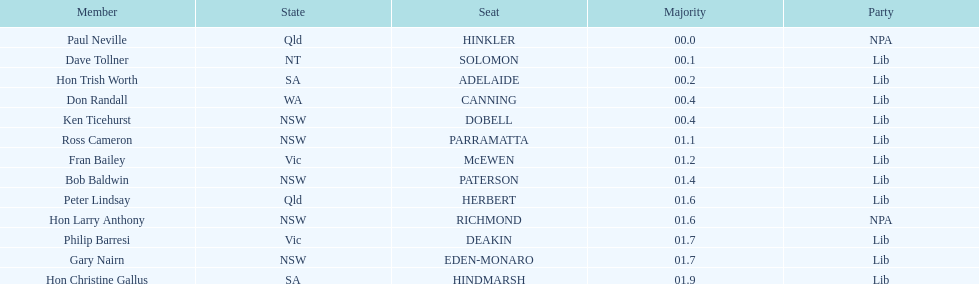What is the difference in majority between hindmarsh and hinkler? 01.9. I'm looking to parse the entire table for insights. Could you assist me with that? {'header': ['Member', 'State', 'Seat', 'Majority', 'Party'], 'rows': [['Paul Neville', 'Qld', 'HINKLER', '00.0', 'NPA'], ['Dave Tollner', 'NT', 'SOLOMON', '00.1', 'Lib'], ['Hon Trish Worth', 'SA', 'ADELAIDE', '00.2', 'Lib'], ['Don Randall', 'WA', 'CANNING', '00.4', 'Lib'], ['Ken Ticehurst', 'NSW', 'DOBELL', '00.4', 'Lib'], ['Ross Cameron', 'NSW', 'PARRAMATTA', '01.1', 'Lib'], ['Fran Bailey', 'Vic', 'McEWEN', '01.2', 'Lib'], ['Bob Baldwin', 'NSW', 'PATERSON', '01.4', 'Lib'], ['Peter Lindsay', 'Qld', 'HERBERT', '01.6', 'Lib'], ['Hon Larry Anthony', 'NSW', 'RICHMOND', '01.6', 'NPA'], ['Philip Barresi', 'Vic', 'DEAKIN', '01.7', 'Lib'], ['Gary Nairn', 'NSW', 'EDEN-MONARO', '01.7', 'Lib'], ['Hon Christine Gallus', 'SA', 'HINDMARSH', '01.9', 'Lib']]} 